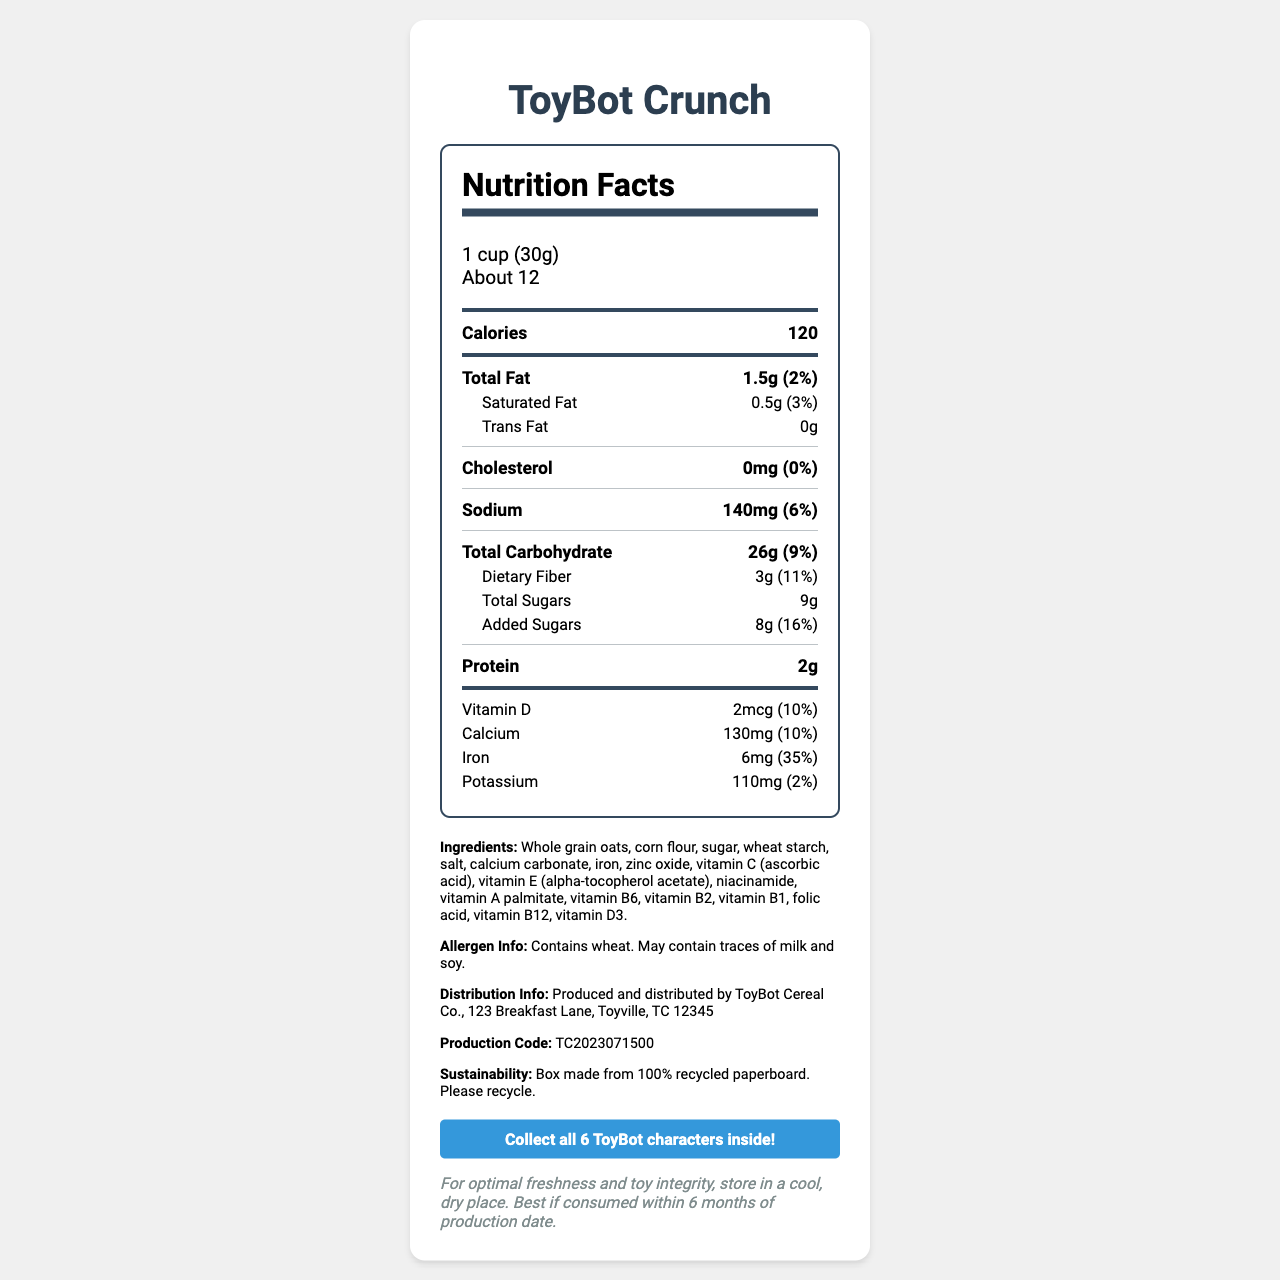what is the serving size? The serving size is stated in the "serving info" section under Nutrition Facts.
Answer: 1 cup (30g) how many servings are in the container? The servings per container are stated in the "serving info" section under Nutrition Facts.
Answer: About 12 what is the total carbohydrate content per serving? The total carbohydrate content is listed under the "Total Carbohydrate" section within Nutrition Facts.
Answer: 26g how much iron does each serving contain? The iron content is listed under the "Iron" section within Nutrition Facts.
Answer: 6mg (35%) what are the main ingredients? The ingredients are listed in the additional info section of the document.
Answer: Whole grain oats, corn flour, sugar, wheat starch, salt, calcium carbonate, iron, zinc oxide, vitamin C (ascorbic acid), vitamin E (alpha-tocopherol acetate), niacinamide, vitamin A palmitate, vitamin B6, vitamin B2, vitamin B1, folic acid, vitamin B12, vitamin D3. how much protein is in each serving? A. 1g B. 2g C. 3g D. 4g The protein content per serving is listed in the "Protein" section within Nutrition Facts.
Answer: B. 2g which vitamin has the highest percent daily value per serving? A. Vitamin D B. Calcium C. Iron D. Potassium The iron content has a percent daily value of 35%, which is the highest among the listed vitamins and minerals in the document.
Answer: C. Iron does this cereal contain any allergens? The allergen information states "Contains wheat. May contain traces of milk and soy."
Answer: Yes describe the main idea of the document. The document provides comprehensive nutrition information, ingredients, and promotional aspects for ToyBot Crunch cereal.
Answer: The document is a Nutrition Facts label for ToyBot Crunch cereal, detailing serving size, nutritional content, ingredients, allergens, and promotional information about collectible ToyBot characters inside. what is the most important logistical note provided? The logistics note advises on proper storage and consumption timeline to maintain quality and toy integrity.
Answer: For optimal freshness and toy integrity, store in a cool, dry place. Best if consumed within 6 months of production date. what is the production code of this cereal? The production code is listed in the additional info section of the document.
Answer: TC2023071500 how much total fat is in a serving of this cereal? The total fat content per serving is listed under the "Total Fat" section within Nutrition Facts.
Answer: 1.5g (2%) does the cereal contain trans fat? The trans fat content is listed as 0g within Nutrition Facts.
Answer: No what company produces and distributes this cereal? The distribution info section lists the producing and distributing company as ToyBot Cereal Co.
Answer: ToyBot Cereal Co., 123 Breakfast Lane, Toyville, TC 12345 is this document indicating that the box is recyclable? The sustainability section states, "Box made from 100% recycled paperboard. Please recycle."
Answer: Yes how much dietary fiber is in each serving? The dietary fiber content per serving is listed under the "Dietary Fiber" section within Nutrition Facts.
Answer: 3g (11%) what is the expiration period for the cereal from the production date? The logistics note states that the cereal is best if consumed within 6 months of production date.
Answer: Six months can you determine the manufacturing date from the data provided? The production code is given, but there is no direct manufacturing date provided within the document.
Answer: Not enough information is there promotional information about collectible toys? The promotional info clearly states the collection of six ToyBot characters.
Answer: Yes, Collect all 6 ToyBot characters inside! 